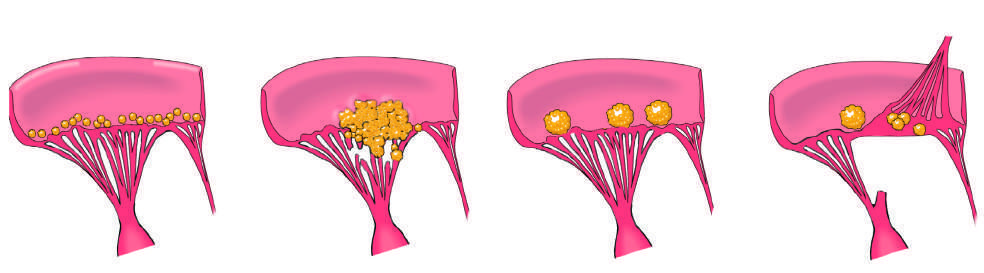what is the acute rheumatic fever phase of rheumatic heart disease marked by?
Answer the question using a single word or phrase. The appearance of small 